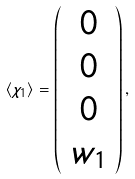Convert formula to latex. <formula><loc_0><loc_0><loc_500><loc_500>\langle \chi _ { 1 } \rangle = \left ( \begin{array} { c } 0 \\ 0 \\ 0 \\ w _ { 1 } \end{array} \right ) ,</formula> 